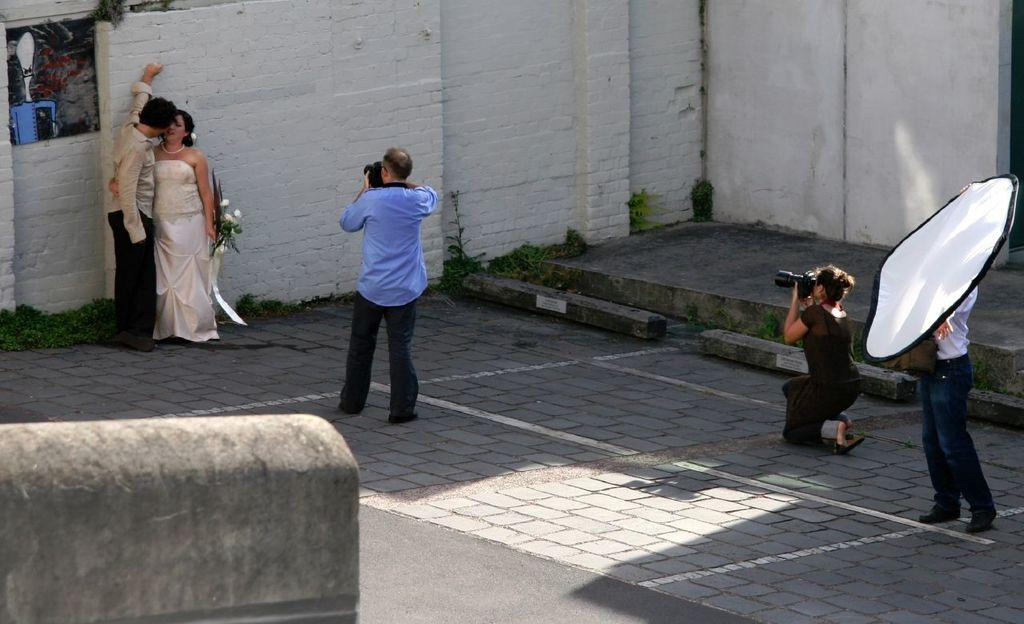How many people are in the image? There are three people in the image. What are the two people standing beside the wall doing? They are holding a camera. What is the third person holding? The third person is holding a white sheet. What type of clam can be seen crawling on the wall in the image? There are no clams present in the image; it features three people and a camera. Is there any smoke visible in the image? No, there is no smoke visible in the image. 